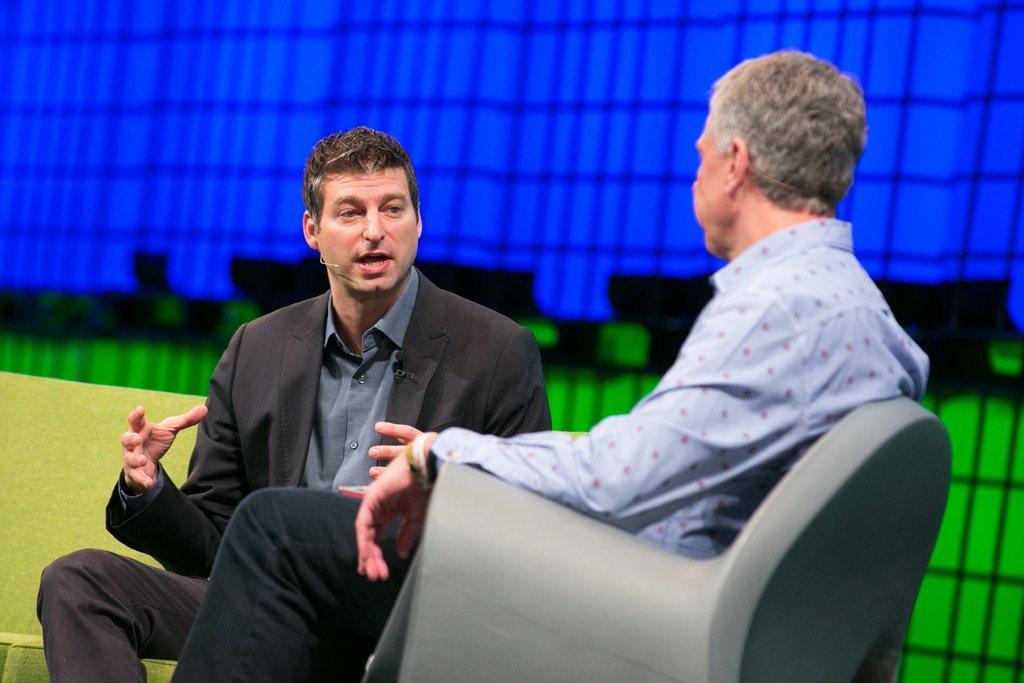How many people are in the image? There are two persons in the image. What are the two persons doing in the image? The two persons are sitting on a sofa. What can be seen in the background of the image? There is a wall in the background of the image. What type of crib is visible in the image? There is no crib present in the image. What is the ice condition in the image? There is no ice present in the image, so it cannot be determined if it is cold or not. 